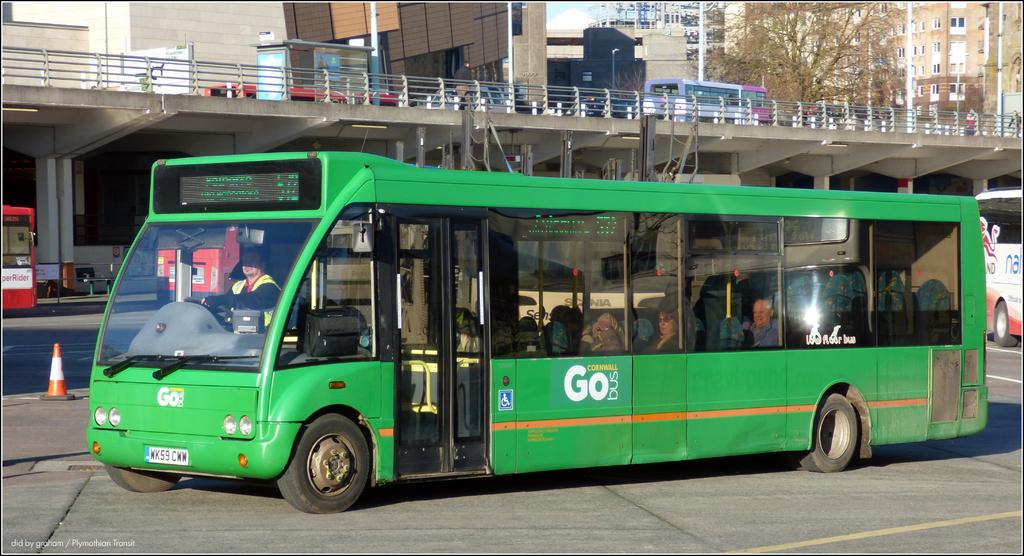What two letters are written on the green bus, in white?
Offer a terse response. Go. What is the license plate of the bus?
Your answer should be compact. Unanswerable. 